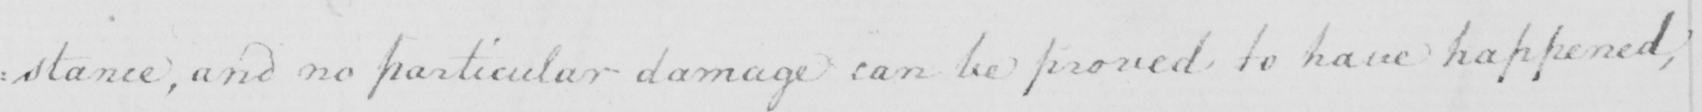Please provide the text content of this handwritten line. : stance , and no particular damage can be proved to have happened , 